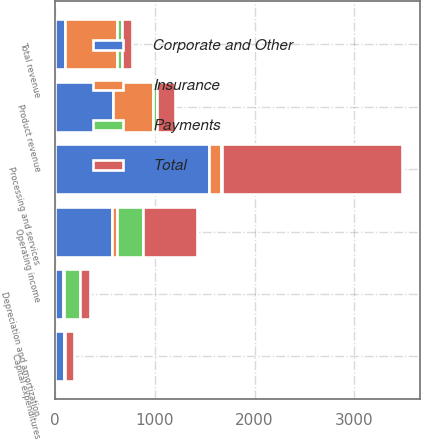Convert chart to OTSL. <chart><loc_0><loc_0><loc_500><loc_500><stacked_bar_chart><ecel><fcel>Processing and services<fcel>Product revenue<fcel>Total revenue<fcel>Operating income<fcel>Capital expenditures<fcel>Depreciation and amortization<nl><fcel>Corporate and Other<fcel>1542<fcel>589<fcel>108<fcel>579<fcel>94<fcel>88<nl><fcel>Total<fcel>1808<fcel>184<fcel>108<fcel>545<fcel>95<fcel>92<nl><fcel>Insurance<fcel>121<fcel>392<fcel>513<fcel>44<fcel>7<fcel>6<nl><fcel>Payments<fcel>7<fcel>42<fcel>49<fcel>260<fcel>2<fcel>164<nl></chart> 